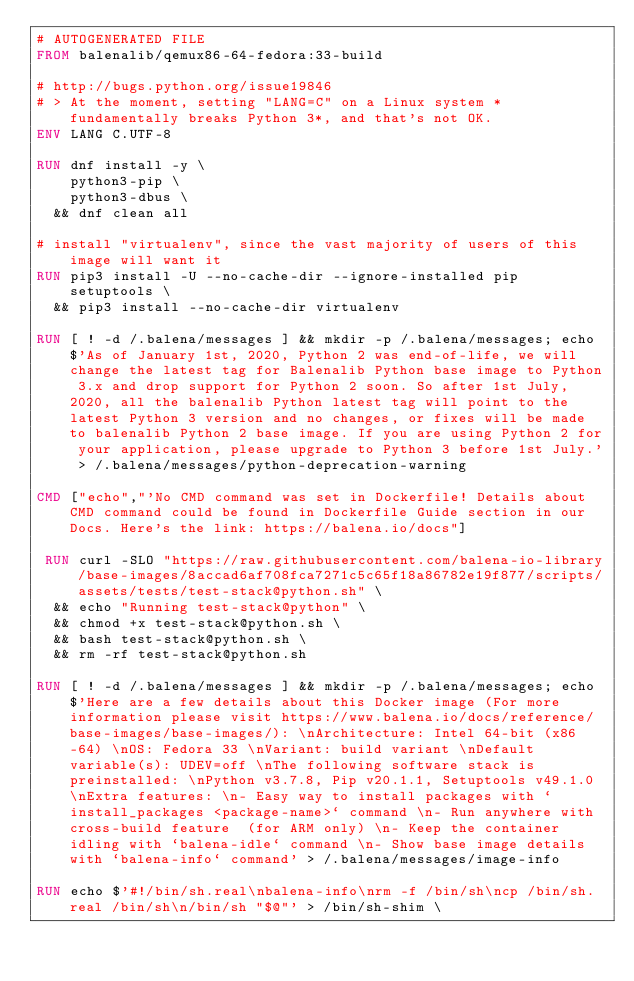<code> <loc_0><loc_0><loc_500><loc_500><_Dockerfile_># AUTOGENERATED FILE
FROM balenalib/qemux86-64-fedora:33-build

# http://bugs.python.org/issue19846
# > At the moment, setting "LANG=C" on a Linux system *fundamentally breaks Python 3*, and that's not OK.
ENV LANG C.UTF-8

RUN dnf install -y \
		python3-pip \
		python3-dbus \
	&& dnf clean all

# install "virtualenv", since the vast majority of users of this image will want it
RUN pip3 install -U --no-cache-dir --ignore-installed pip setuptools \
	&& pip3 install --no-cache-dir virtualenv

RUN [ ! -d /.balena/messages ] && mkdir -p /.balena/messages; echo $'As of January 1st, 2020, Python 2 was end-of-life, we will change the latest tag for Balenalib Python base image to Python 3.x and drop support for Python 2 soon. So after 1st July, 2020, all the balenalib Python latest tag will point to the latest Python 3 version and no changes, or fixes will be made to balenalib Python 2 base image. If you are using Python 2 for your application, please upgrade to Python 3 before 1st July.' > /.balena/messages/python-deprecation-warning

CMD ["echo","'No CMD command was set in Dockerfile! Details about CMD command could be found in Dockerfile Guide section in our Docs. Here's the link: https://balena.io/docs"]

 RUN curl -SLO "https://raw.githubusercontent.com/balena-io-library/base-images/8accad6af708fca7271c5c65f18a86782e19f877/scripts/assets/tests/test-stack@python.sh" \
  && echo "Running test-stack@python" \
  && chmod +x test-stack@python.sh \
  && bash test-stack@python.sh \
  && rm -rf test-stack@python.sh 

RUN [ ! -d /.balena/messages ] && mkdir -p /.balena/messages; echo $'Here are a few details about this Docker image (For more information please visit https://www.balena.io/docs/reference/base-images/base-images/): \nArchitecture: Intel 64-bit (x86-64) \nOS: Fedora 33 \nVariant: build variant \nDefault variable(s): UDEV=off \nThe following software stack is preinstalled: \nPython v3.7.8, Pip v20.1.1, Setuptools v49.1.0 \nExtra features: \n- Easy way to install packages with `install_packages <package-name>` command \n- Run anywhere with cross-build feature  (for ARM only) \n- Keep the container idling with `balena-idle` command \n- Show base image details with `balena-info` command' > /.balena/messages/image-info

RUN echo $'#!/bin/sh.real\nbalena-info\nrm -f /bin/sh\ncp /bin/sh.real /bin/sh\n/bin/sh "$@"' > /bin/sh-shim \</code> 